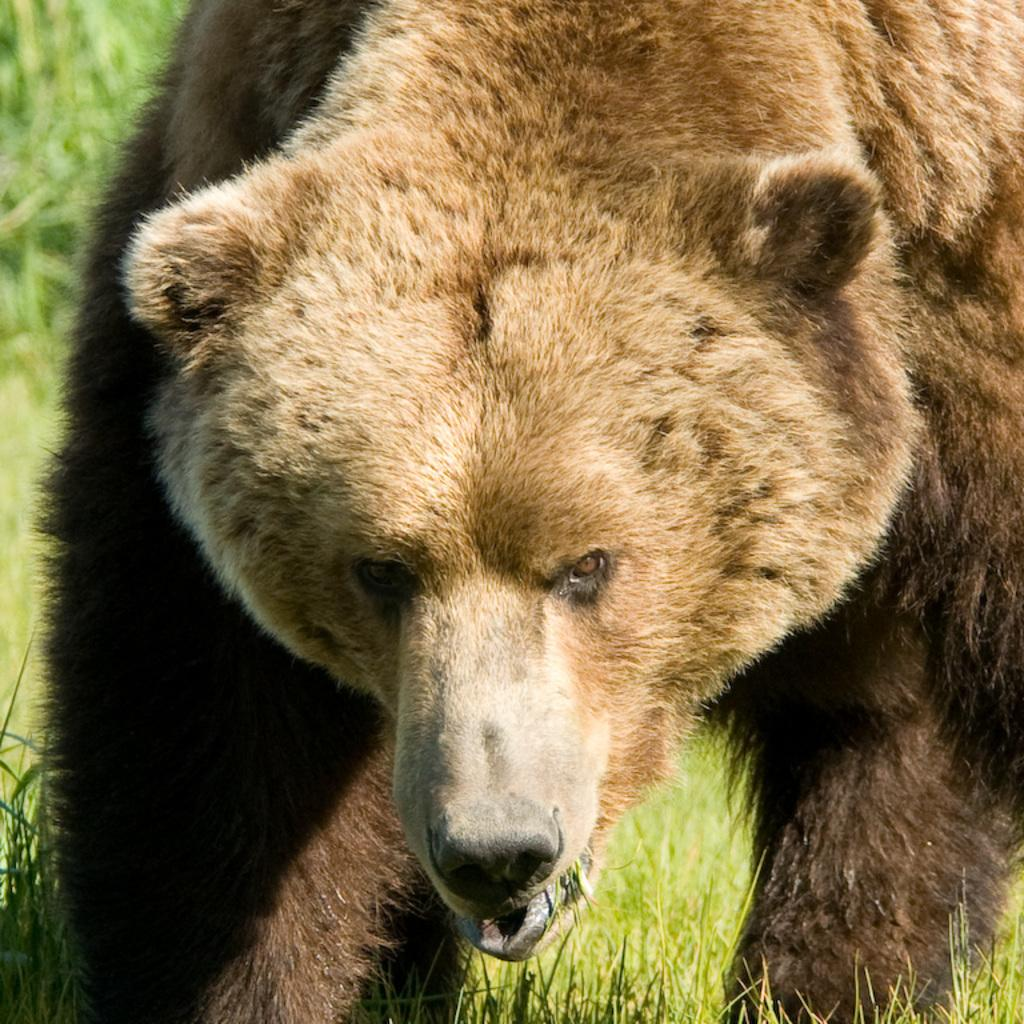What animal is in the picture? There is a bear in the picture. Where is the bear located? The bear is on the grass. Can you see a person holding a knife and riding a bike in the picture? No, there is no person, knife, or bike present in the image; it only features a bear on the grass. 